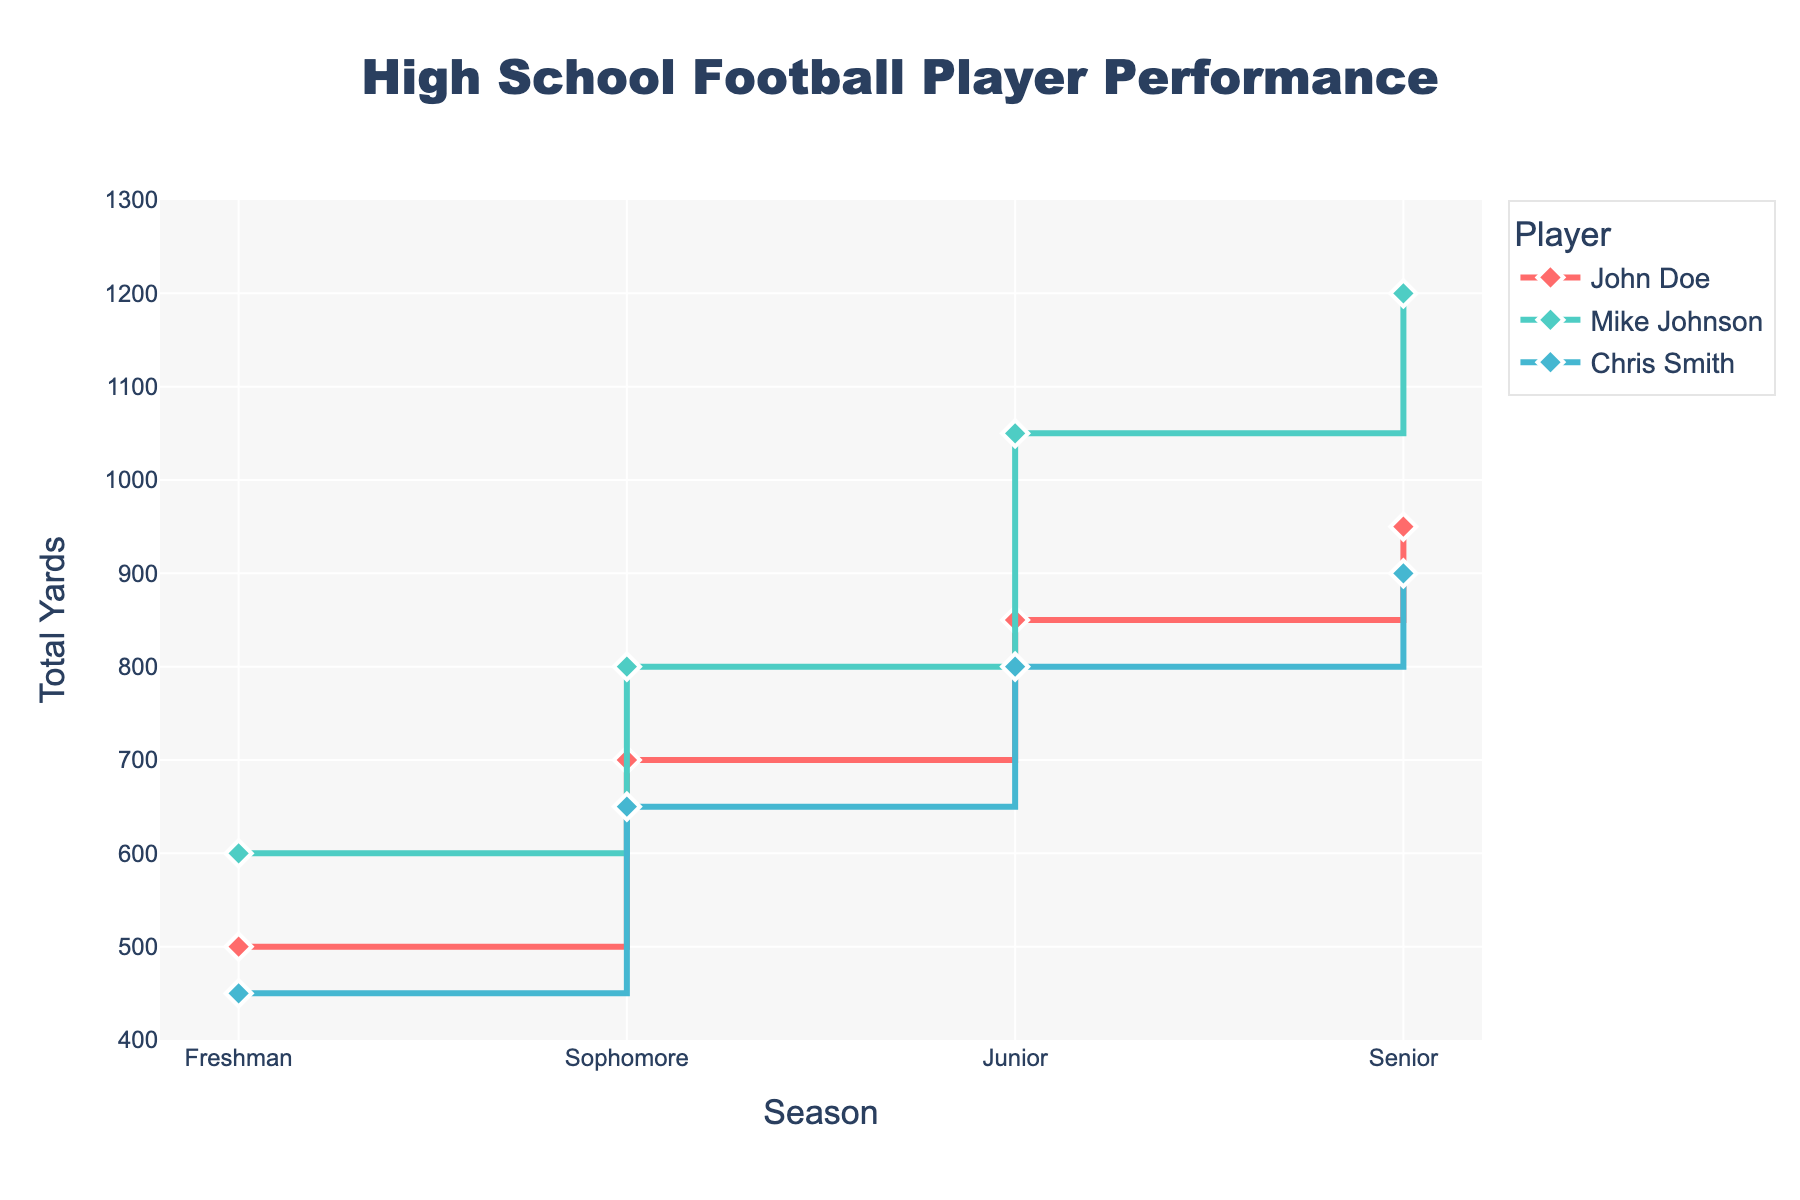what's the title of the plot? The title of the plot is usually displayed prominently at the top of the figure, summarizing the content of the plot. In this case, the title is "High School Football Player Performance."
Answer: High School Football Player Performance Which player's performance in terms of total yards increased the most from freshman to senior year? To find this, check the total yards for each player from freshman to senior year and calculate the difference. John Doe's increase is 950 - 500 = 450 yards, Mike Johnson's increase is 1200 - 600 = 600 yards, and Chris Smith's increase is 900 - 450 = 450 yards.
Answer: Mike Johnson How many players are tracked in this plot? Count the number of unique players listed in the legend of the plot. The plot shows three players: John Doe, Mike Johnson, and Chris Smith.
Answer: 3 Which player had the highest total yards in their junior year? Look at the data points for the junior year for each player. John Doe had 850 yards, Mike Johnson had 1050 yards, and Chris Smith had 800 yards.
Answer: Mike Johnson What is the color used for Chris Smith's line? Identify the color of the line associated with Chris Smith by looking at the legend and the corresponding line in the plot. The color used for Chris Smith is #45B7D1.
Answer: #45B7D1 What is the average total yards per season for John Doe? To calculate the average, sum John Doe's total yards for all seasons and divide by the number of seasons. (500 + 700 + 850 + 950) / 4 = 3000 / 4 = 750 yards.
Answer: 750 Which season had the smallest difference in total yards between Mike Johnson and Chris Smith? Calculate the differences in total yards between Mike Johnson and Chris Smith for each season. The smallest difference is found by comparing 600 - 450 = 150 (Freshman), 800 - 650 = 150 (Sophomore), 1050 - 800 = 250 (Junior), and 1200 - 900 = 300 (Senior). Both Freshman and Sophomore seasons have the smallest difference of 150 yards.
Answer: Freshman/Sophomore In which season did John Doe have the highest number of touchdowns? Check the hover text for John Doe's data points across all seasons to find the highest number of touchdowns. John Doe had 13 touchdowns in his senior year.
Answer: Senior Is there any season where all three players had the same number of games played? Verify the number of games played by each player in each season. All three players played eight games in the freshman season, nine games in the sophomore season, ten games in the junior season, and eleven games in the senior season. The pattern remains consistent every season.
Answer: All Seasons 